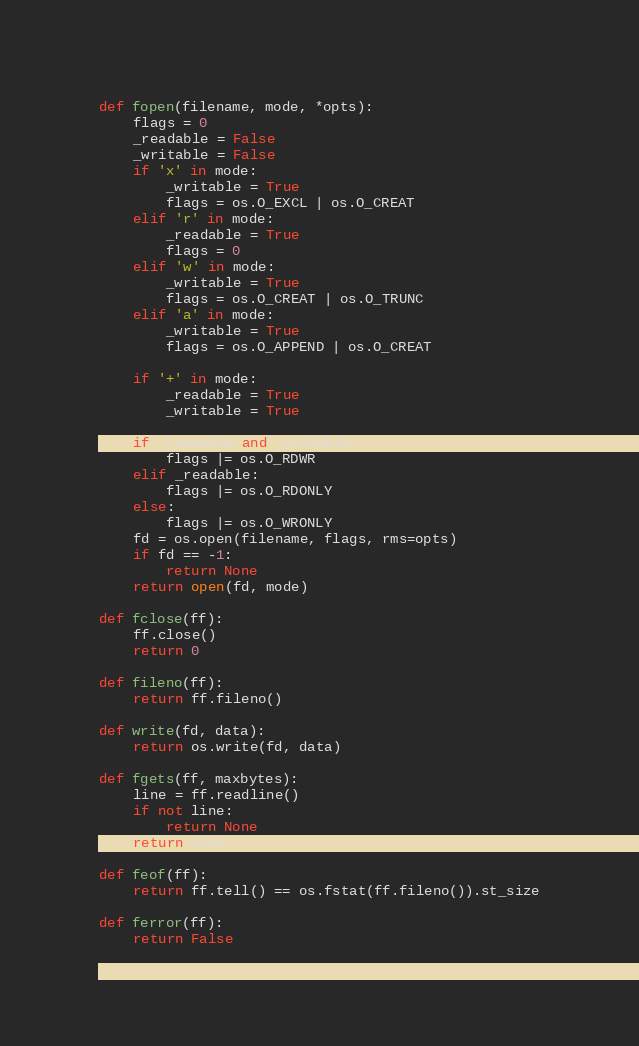Convert code to text. <code><loc_0><loc_0><loc_500><loc_500><_Python_>def fopen(filename, mode, *opts):
    flags = 0
    _readable = False
    _writable = False
    if 'x' in mode:
        _writable = True
        flags = os.O_EXCL | os.O_CREAT
    elif 'r' in mode:
        _readable = True
        flags = 0
    elif 'w' in mode:
        _writable = True
        flags = os.O_CREAT | os.O_TRUNC
    elif 'a' in mode:
        _writable = True
        flags = os.O_APPEND | os.O_CREAT

    if '+' in mode:
        _readable = True
        _writable = True

    if _readable and _writable:
        flags |= os.O_RDWR
    elif _readable:
        flags |= os.O_RDONLY
    else:
        flags |= os.O_WRONLY
    fd = os.open(filename, flags, rms=opts)
    if fd == -1:
        return None
    return open(fd, mode)

def fclose(ff):
    ff.close()
    return 0

def fileno(ff):
    return ff.fileno()

def write(fd, data):
    return os.write(fd, data)

def fgets(ff, maxbytes):
    line = ff.readline()
    if not line:
        return None
    return line

def feof(ff):
    return ff.tell() == os.fstat(ff.fileno()).st_size

def ferror(ff):
    return False
</code> 